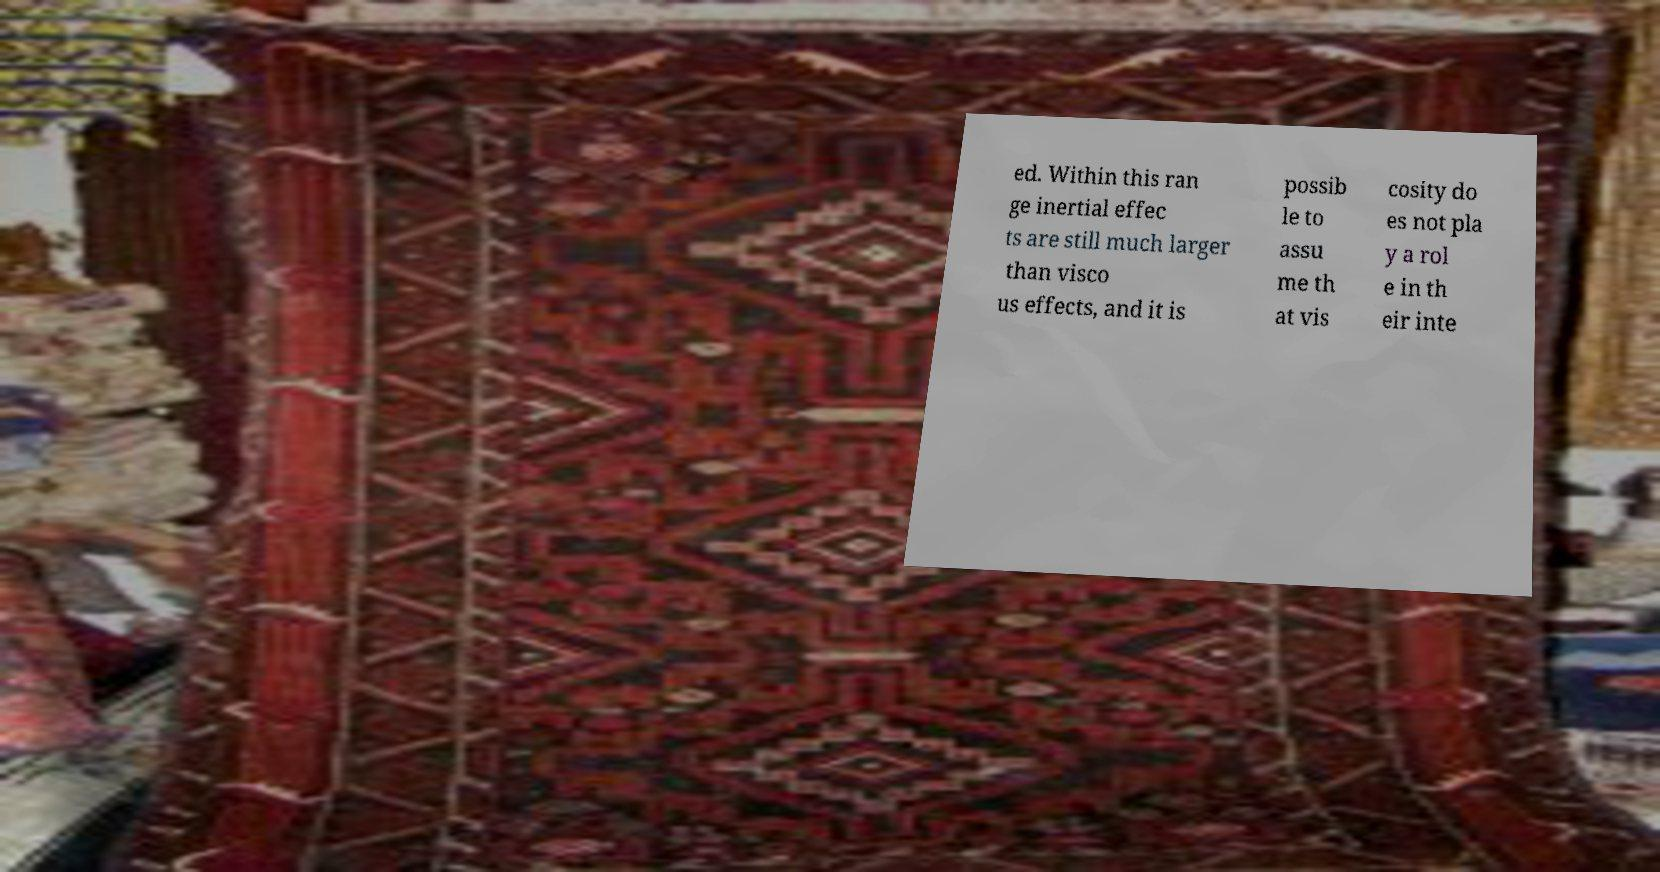Can you accurately transcribe the text from the provided image for me? ed. Within this ran ge inertial effec ts are still much larger than visco us effects, and it is possib le to assu me th at vis cosity do es not pla y a rol e in th eir inte 